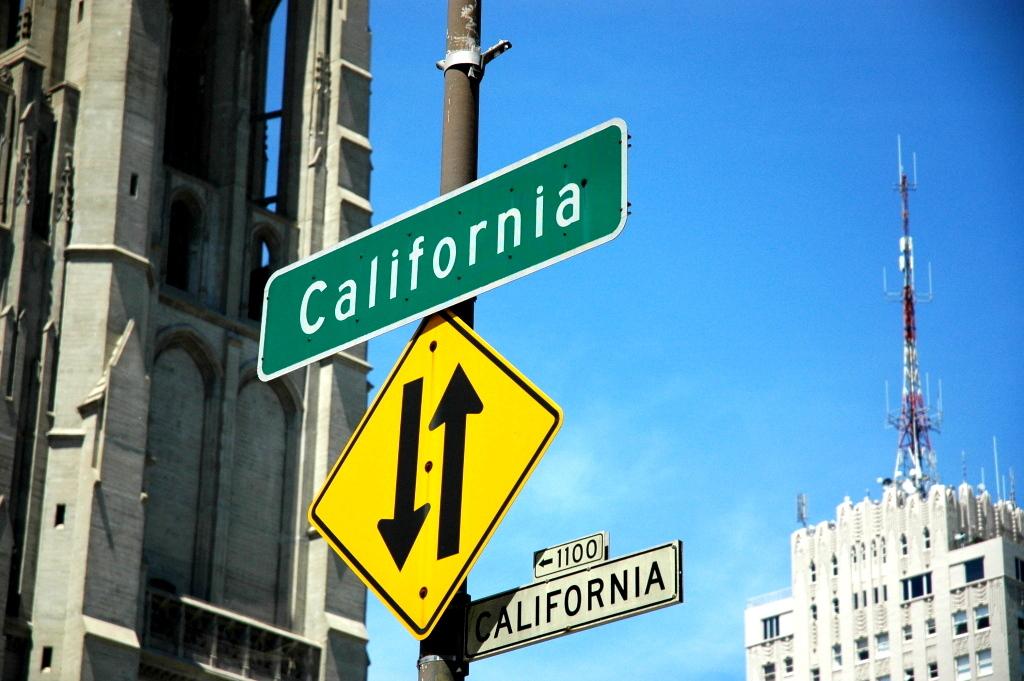What is the first letter of the word written on the green sign?
Make the answer very short. C. 